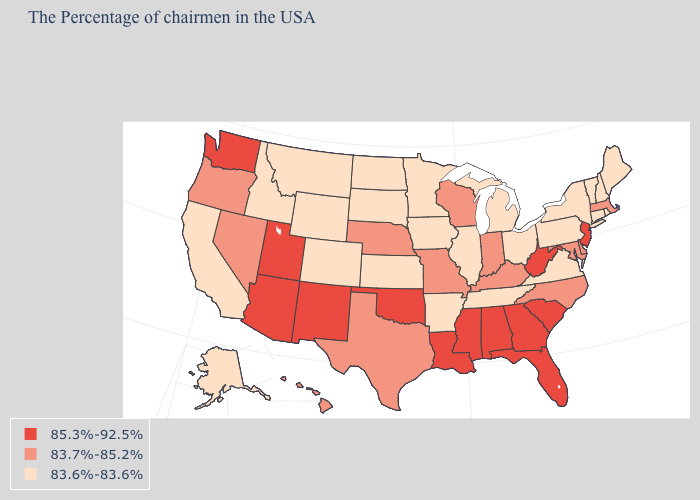What is the lowest value in states that border Delaware?
Give a very brief answer. 83.6%-83.6%. Name the states that have a value in the range 83.6%-83.6%?
Concise answer only. Maine, Rhode Island, New Hampshire, Vermont, Connecticut, New York, Pennsylvania, Virginia, Ohio, Michigan, Tennessee, Illinois, Arkansas, Minnesota, Iowa, Kansas, South Dakota, North Dakota, Wyoming, Colorado, Montana, Idaho, California, Alaska. Which states hav the highest value in the West?
Write a very short answer. New Mexico, Utah, Arizona, Washington. Does Missouri have the same value as Oregon?
Give a very brief answer. Yes. Which states hav the highest value in the MidWest?
Be succinct. Indiana, Wisconsin, Missouri, Nebraska. Does New Hampshire have the lowest value in the USA?
Short answer required. Yes. Does Kansas have the highest value in the MidWest?
Quick response, please. No. Name the states that have a value in the range 85.3%-92.5%?
Give a very brief answer. New Jersey, South Carolina, West Virginia, Florida, Georgia, Alabama, Mississippi, Louisiana, Oklahoma, New Mexico, Utah, Arizona, Washington. What is the value of Missouri?
Quick response, please. 83.7%-85.2%. Which states have the highest value in the USA?
Short answer required. New Jersey, South Carolina, West Virginia, Florida, Georgia, Alabama, Mississippi, Louisiana, Oklahoma, New Mexico, Utah, Arizona, Washington. Which states have the highest value in the USA?
Give a very brief answer. New Jersey, South Carolina, West Virginia, Florida, Georgia, Alabama, Mississippi, Louisiana, Oklahoma, New Mexico, Utah, Arizona, Washington. What is the lowest value in the USA?
Give a very brief answer. 83.6%-83.6%. What is the lowest value in the Northeast?
Answer briefly. 83.6%-83.6%. Does Colorado have the same value as Idaho?
Give a very brief answer. Yes. Is the legend a continuous bar?
Give a very brief answer. No. 